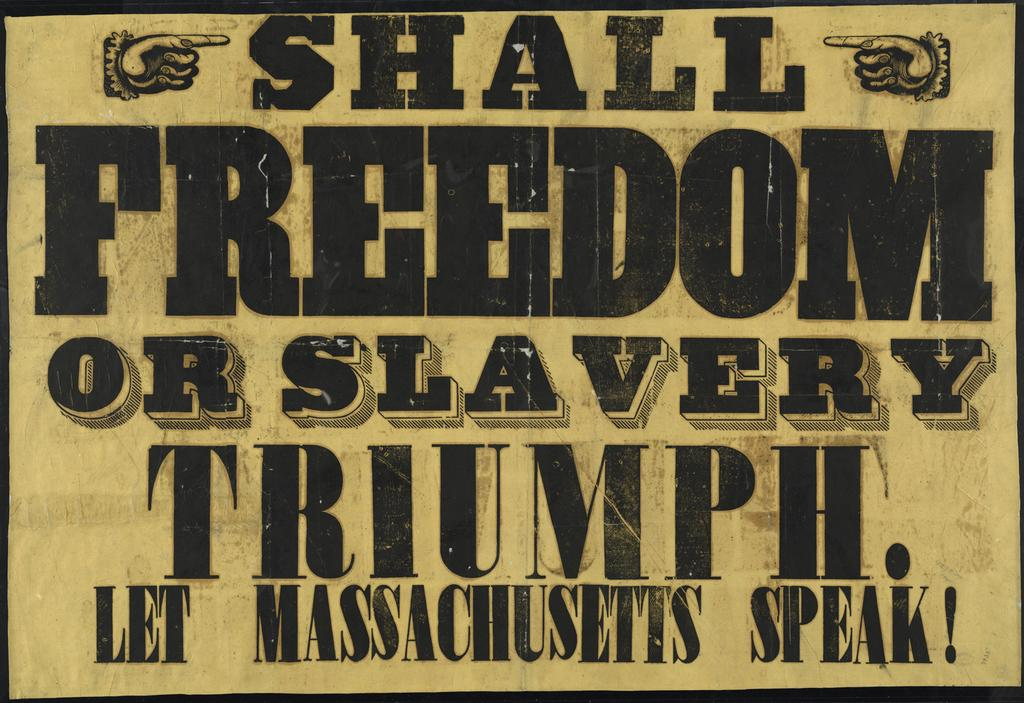Provide a one-sentence caption for the provided image. A sign has two hands with fingers pointing to the word shall. 